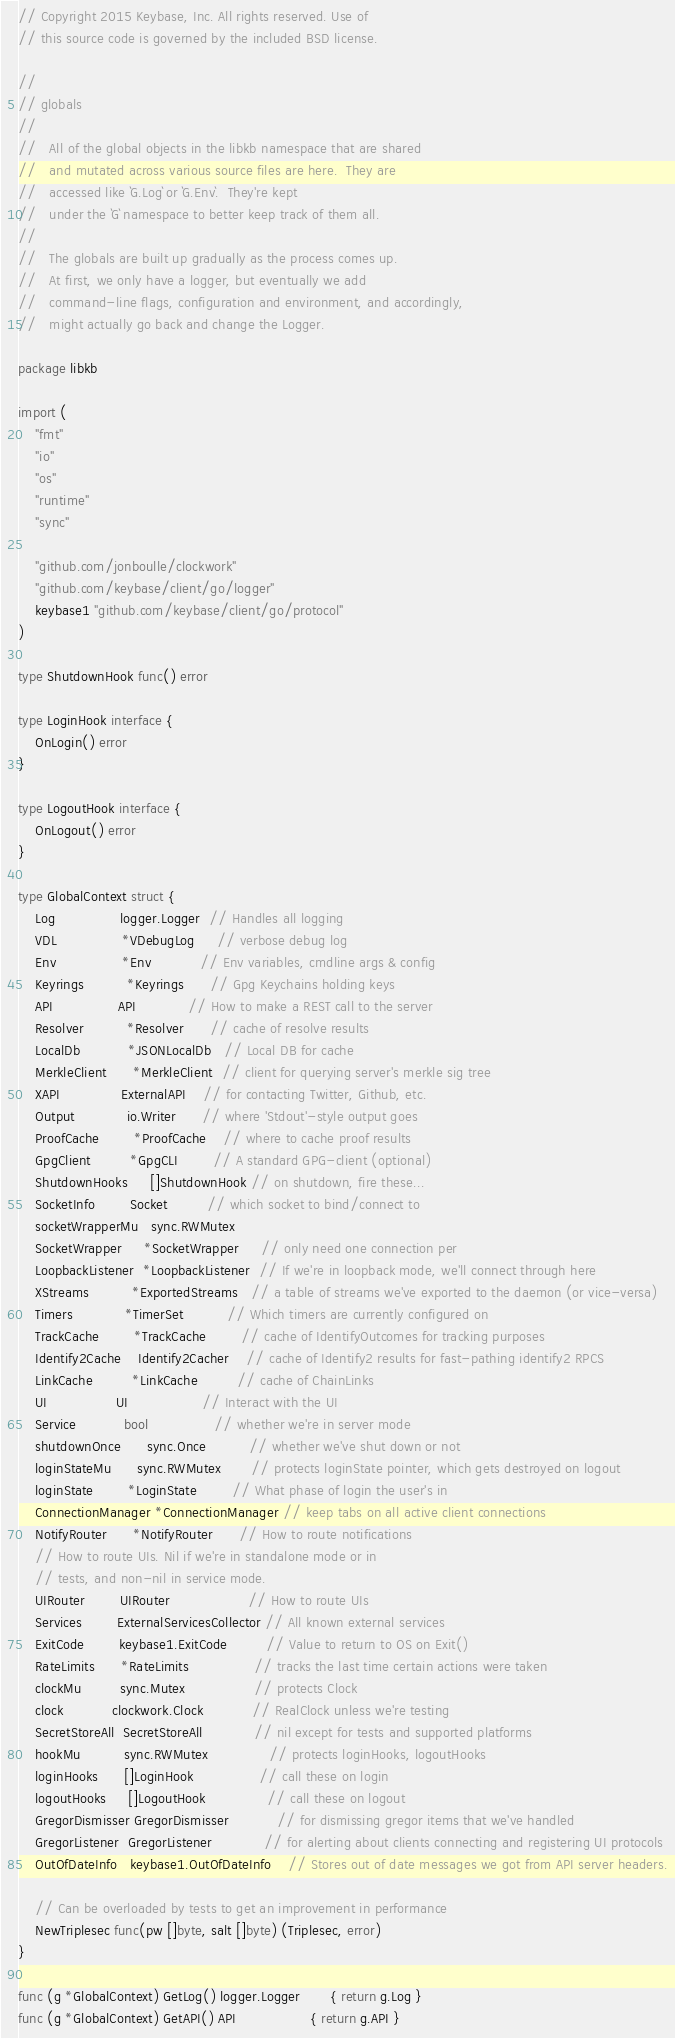<code> <loc_0><loc_0><loc_500><loc_500><_Go_>// Copyright 2015 Keybase, Inc. All rights reserved. Use of
// this source code is governed by the included BSD license.

//
// globals
//
//   All of the global objects in the libkb namespace that are shared
//   and mutated across various source files are here.  They are
//   accessed like `G.Log` or `G.Env`.  They're kept
//   under the `G` namespace to better keep track of them all.
//
//   The globals are built up gradually as the process comes up.
//   At first, we only have a logger, but eventually we add
//   command-line flags, configuration and environment, and accordingly,
//   might actually go back and change the Logger.

package libkb

import (
	"fmt"
	"io"
	"os"
	"runtime"
	"sync"

	"github.com/jonboulle/clockwork"
	"github.com/keybase/client/go/logger"
	keybase1 "github.com/keybase/client/go/protocol"
)

type ShutdownHook func() error

type LoginHook interface {
	OnLogin() error
}

type LogoutHook interface {
	OnLogout() error
}

type GlobalContext struct {
	Log               logger.Logger  // Handles all logging
	VDL               *VDebugLog     // verbose debug log
	Env               *Env           // Env variables, cmdline args & config
	Keyrings          *Keyrings      // Gpg Keychains holding keys
	API               API            // How to make a REST call to the server
	Resolver          *Resolver      // cache of resolve results
	LocalDb           *JSONLocalDb   // Local DB for cache
	MerkleClient      *MerkleClient  // client for querying server's merkle sig tree
	XAPI              ExternalAPI    // for contacting Twitter, Github, etc.
	Output            io.Writer      // where 'Stdout'-style output goes
	ProofCache        *ProofCache    // where to cache proof results
	GpgClient         *GpgCLI        // A standard GPG-client (optional)
	ShutdownHooks     []ShutdownHook // on shutdown, fire these...
	SocketInfo        Socket         // which socket to bind/connect to
	socketWrapperMu   sync.RWMutex
	SocketWrapper     *SocketWrapper     // only need one connection per
	LoopbackListener  *LoopbackListener  // If we're in loopback mode, we'll connect through here
	XStreams          *ExportedStreams   // a table of streams we've exported to the daemon (or vice-versa)
	Timers            *TimerSet          // Which timers are currently configured on
	TrackCache        *TrackCache        // cache of IdentifyOutcomes for tracking purposes
	Identify2Cache    Identify2Cacher    // cache of Identify2 results for fast-pathing identify2 RPCS
	LinkCache         *LinkCache         // cache of ChainLinks
	UI                UI                 // Interact with the UI
	Service           bool               // whether we're in server mode
	shutdownOnce      sync.Once          // whether we've shut down or not
	loginStateMu      sync.RWMutex       // protects loginState pointer, which gets destroyed on logout
	loginState        *LoginState        // What phase of login the user's in
	ConnectionManager *ConnectionManager // keep tabs on all active client connections
	NotifyRouter      *NotifyRouter      // How to route notifications
	// How to route UIs. Nil if we're in standalone mode or in
	// tests, and non-nil in service mode.
	UIRouter        UIRouter                  // How to route UIs
	Services        ExternalServicesCollector // All known external services
	ExitCode        keybase1.ExitCode         // Value to return to OS on Exit()
	RateLimits      *RateLimits               // tracks the last time certain actions were taken
	clockMu         sync.Mutex                // protects Clock
	clock           clockwork.Clock           // RealClock unless we're testing
	SecretStoreAll  SecretStoreAll            // nil except for tests and supported platforms
	hookMu          sync.RWMutex              // protects loginHooks, logoutHooks
	loginHooks      []LoginHook               // call these on login
	logoutHooks     []LogoutHook              // call these on logout
	GregorDismisser GregorDismisser           // for dismissing gregor items that we've handled
	GregorListener  GregorListener            // for alerting about clients connecting and registering UI protocols
	OutOfDateInfo   keybase1.OutOfDateInfo    // Stores out of date messages we got from API server headers.

	// Can be overloaded by tests to get an improvement in performance
	NewTriplesec func(pw []byte, salt []byte) (Triplesec, error)
}

func (g *GlobalContext) GetLog() logger.Logger       { return g.Log }
func (g *GlobalContext) GetAPI() API                 { return g.API }</code> 